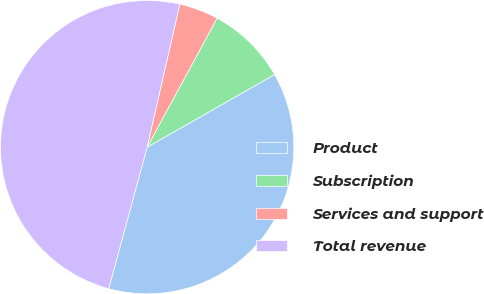Convert chart. <chart><loc_0><loc_0><loc_500><loc_500><pie_chart><fcel>Product<fcel>Subscription<fcel>Services and support<fcel>Total revenue<nl><fcel>37.46%<fcel>8.85%<fcel>4.34%<fcel>49.35%<nl></chart> 